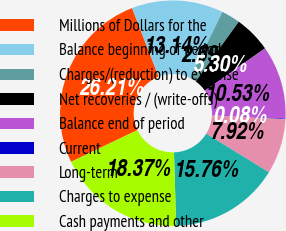<chart> <loc_0><loc_0><loc_500><loc_500><pie_chart><fcel>Millions of Dollars for the<fcel>Balance beginning of period<fcel>Charges/(reduction) to expense<fcel>Net recoveries / (write-offs)<fcel>Balance end of period<fcel>Current<fcel>Long-term<fcel>Charges to expense<fcel>Cash payments and other<nl><fcel>26.21%<fcel>13.14%<fcel>2.69%<fcel>5.3%<fcel>10.53%<fcel>0.08%<fcel>7.92%<fcel>15.76%<fcel>18.37%<nl></chart> 